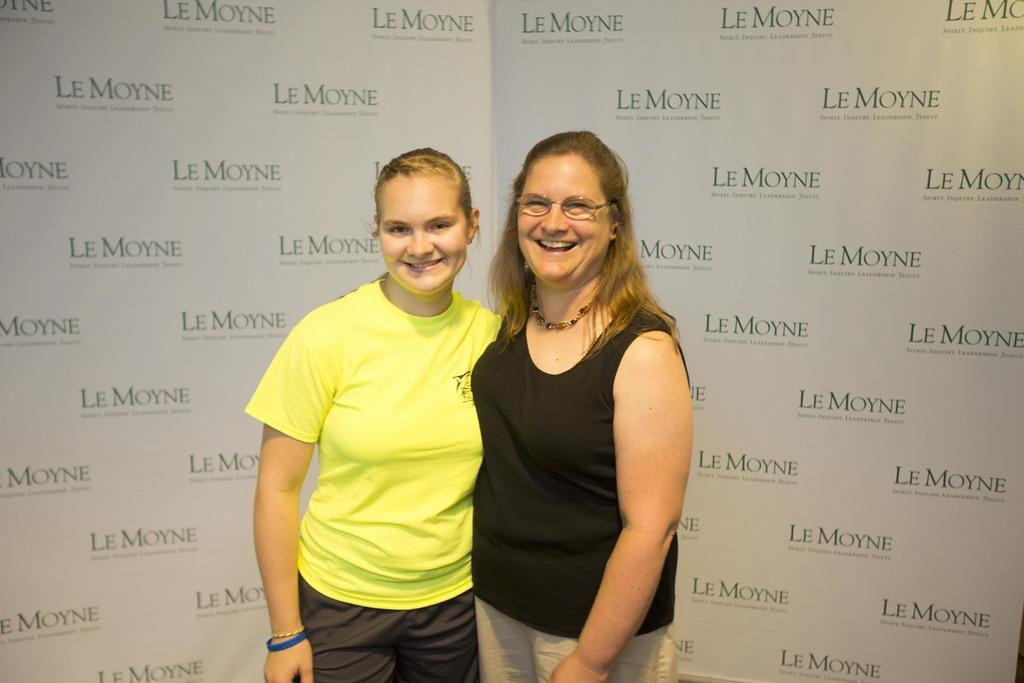How many people are in the image? There are two women in the image. Where are the women located in the image? The women are standing in the foreground. What else can be seen in the image besides the women? There are names of sponsors visible in the image. What type of scarecrow is visible in the background of the image? There is no scarecrow present in the image; it only features two women and sponsor names. 